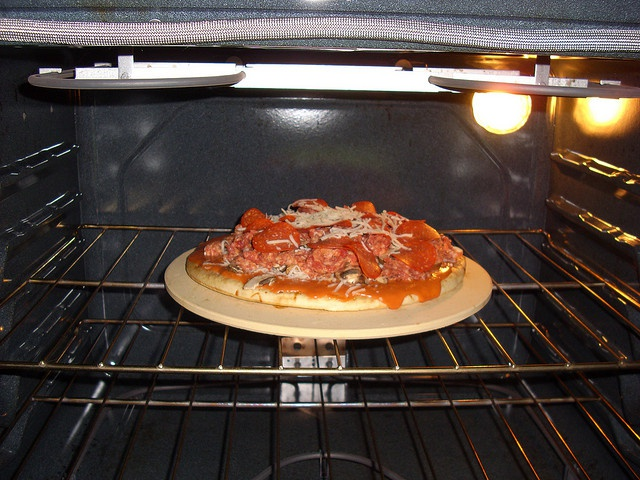Describe the objects in this image and their specific colors. I can see oven in black, gray, white, maroon, and brown tones and pizza in black, brown, red, and tan tones in this image. 